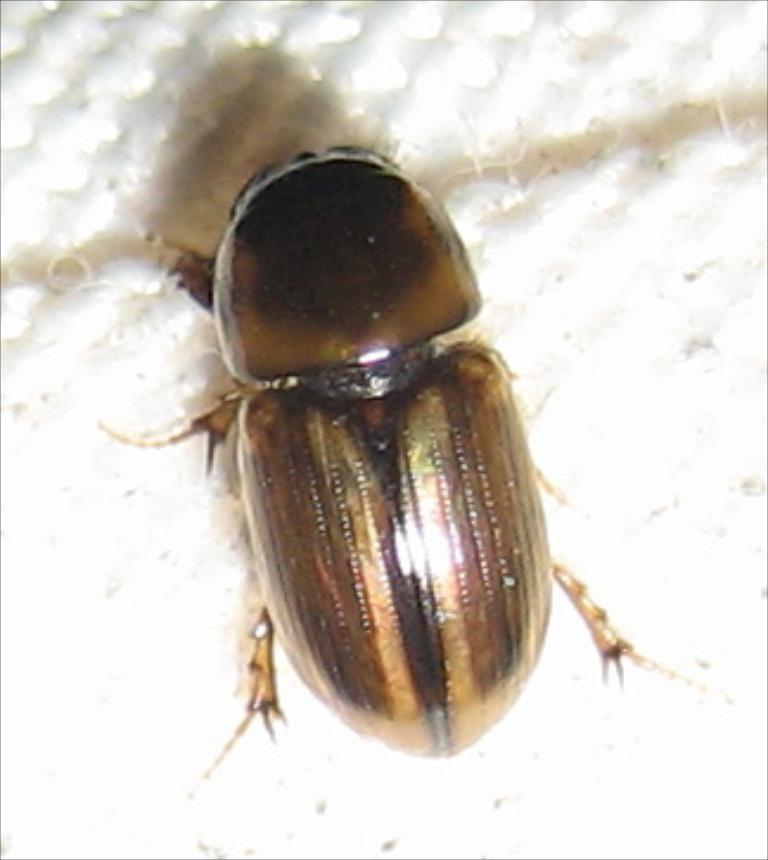What type of creature is in the image? There is an insect in the image. What colors can be seen on the insect? The insect has brown and black colors. What is the background color in the image? The insect is on a white color surface. What force is being applied to the insect in the image? There is no force being applied to the insect in the image; it is simply resting on the white surface. Can you describe the cub that is present in the image? There is no cub present in the image; it features an insect on a white surface. 